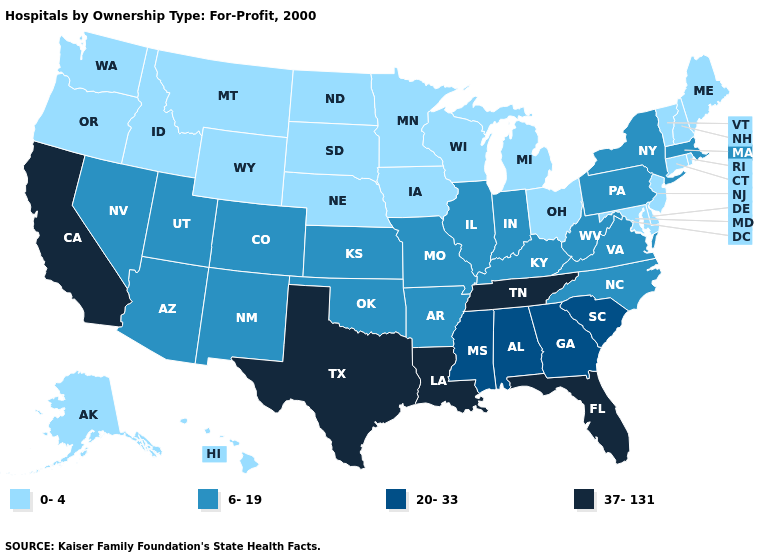Does Maryland have the lowest value in the South?
Quick response, please. Yes. Name the states that have a value in the range 37-131?
Concise answer only. California, Florida, Louisiana, Tennessee, Texas. Which states have the lowest value in the USA?
Concise answer only. Alaska, Connecticut, Delaware, Hawaii, Idaho, Iowa, Maine, Maryland, Michigan, Minnesota, Montana, Nebraska, New Hampshire, New Jersey, North Dakota, Ohio, Oregon, Rhode Island, South Dakota, Vermont, Washington, Wisconsin, Wyoming. Name the states that have a value in the range 37-131?
Quick response, please. California, Florida, Louisiana, Tennessee, Texas. What is the highest value in states that border Texas?
Be succinct. 37-131. Name the states that have a value in the range 37-131?
Quick response, please. California, Florida, Louisiana, Tennessee, Texas. Does North Dakota have the same value as Delaware?
Short answer required. Yes. Name the states that have a value in the range 6-19?
Keep it brief. Arizona, Arkansas, Colorado, Illinois, Indiana, Kansas, Kentucky, Massachusetts, Missouri, Nevada, New Mexico, New York, North Carolina, Oklahoma, Pennsylvania, Utah, Virginia, West Virginia. Does the first symbol in the legend represent the smallest category?
Quick response, please. Yes. What is the lowest value in the West?
Give a very brief answer. 0-4. Does Hawaii have the lowest value in the USA?
Write a very short answer. Yes. What is the value of Wyoming?
Short answer required. 0-4. What is the value of Alabama?
Give a very brief answer. 20-33. Among the states that border Vermont , does Massachusetts have the lowest value?
Quick response, please. No. Name the states that have a value in the range 37-131?
Answer briefly. California, Florida, Louisiana, Tennessee, Texas. 